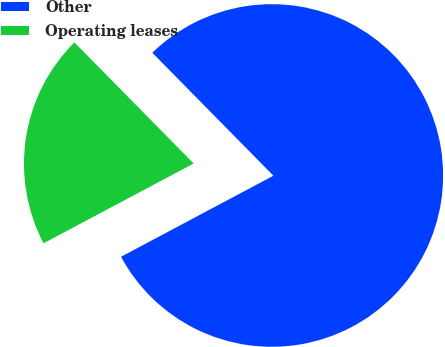Convert chart. <chart><loc_0><loc_0><loc_500><loc_500><pie_chart><fcel>Other<fcel>Operating leases<nl><fcel>79.6%<fcel>20.4%<nl></chart> 